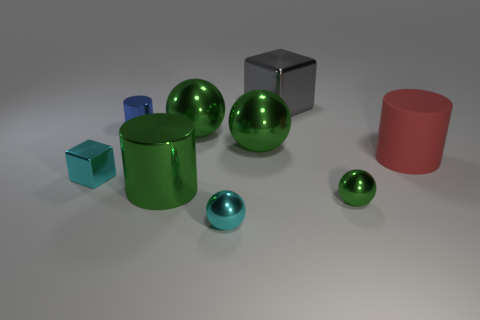How many green spheres must be subtracted to get 1 green spheres? 2 Subtract all red cylinders. How many green balls are left? 3 Subtract 1 balls. How many balls are left? 3 Subtract all cyan balls. How many balls are left? 3 Subtract all big cylinders. How many cylinders are left? 1 Subtract all red balls. Subtract all blue cylinders. How many balls are left? 4 Subtract all cubes. How many objects are left? 7 Subtract all green metal spheres. Subtract all tiny cyan metallic balls. How many objects are left? 5 Add 4 blue metallic cylinders. How many blue metallic cylinders are left? 5 Add 4 tiny gray balls. How many tiny gray balls exist? 4 